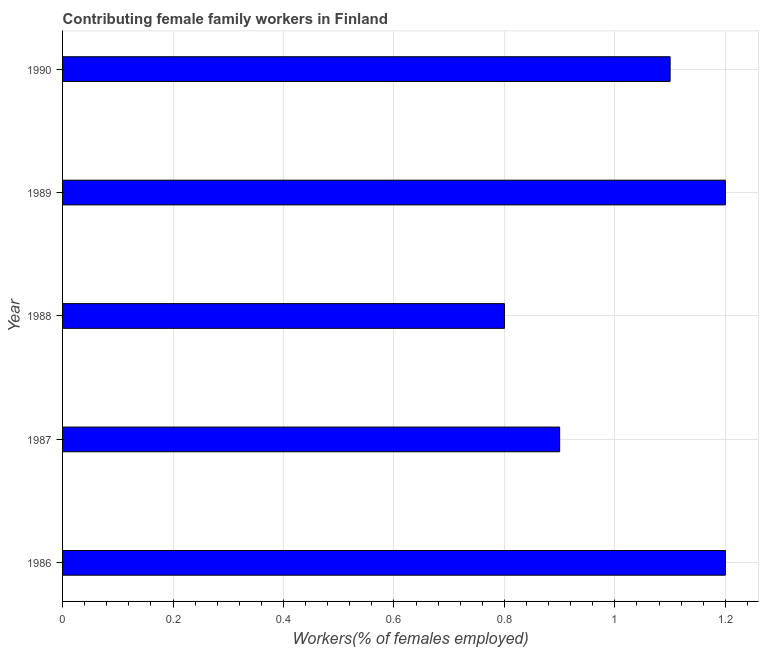What is the title of the graph?
Give a very brief answer. Contributing female family workers in Finland. What is the label or title of the X-axis?
Keep it short and to the point. Workers(% of females employed). What is the contributing female family workers in 1986?
Keep it short and to the point. 1.2. Across all years, what is the maximum contributing female family workers?
Make the answer very short. 1.2. Across all years, what is the minimum contributing female family workers?
Offer a terse response. 0.8. What is the sum of the contributing female family workers?
Your answer should be compact. 5.2. What is the difference between the contributing female family workers in 1989 and 1990?
Make the answer very short. 0.1. What is the average contributing female family workers per year?
Your response must be concise. 1.04. What is the median contributing female family workers?
Your answer should be very brief. 1.1. Do a majority of the years between 1987 and 1989 (inclusive) have contributing female family workers greater than 1 %?
Provide a short and direct response. No. What is the ratio of the contributing female family workers in 1989 to that in 1990?
Your answer should be very brief. 1.09. Is the contributing female family workers in 1988 less than that in 1990?
Make the answer very short. Yes. Is the difference between the contributing female family workers in 1986 and 1988 greater than the difference between any two years?
Your answer should be very brief. Yes. What is the difference between the highest and the lowest contributing female family workers?
Your answer should be compact. 0.4. How many bars are there?
Your answer should be very brief. 5. How many years are there in the graph?
Your answer should be compact. 5. Are the values on the major ticks of X-axis written in scientific E-notation?
Keep it short and to the point. No. What is the Workers(% of females employed) of 1986?
Offer a terse response. 1.2. What is the Workers(% of females employed) of 1987?
Your answer should be very brief. 0.9. What is the Workers(% of females employed) in 1988?
Provide a short and direct response. 0.8. What is the Workers(% of females employed) of 1989?
Offer a very short reply. 1.2. What is the Workers(% of females employed) of 1990?
Make the answer very short. 1.1. What is the difference between the Workers(% of females employed) in 1986 and 1987?
Your answer should be compact. 0.3. What is the difference between the Workers(% of females employed) in 1987 and 1988?
Give a very brief answer. 0.1. What is the difference between the Workers(% of females employed) in 1989 and 1990?
Your answer should be compact. 0.1. What is the ratio of the Workers(% of females employed) in 1986 to that in 1987?
Provide a succinct answer. 1.33. What is the ratio of the Workers(% of females employed) in 1986 to that in 1990?
Your answer should be very brief. 1.09. What is the ratio of the Workers(% of females employed) in 1987 to that in 1990?
Provide a succinct answer. 0.82. What is the ratio of the Workers(% of females employed) in 1988 to that in 1989?
Offer a terse response. 0.67. What is the ratio of the Workers(% of females employed) in 1988 to that in 1990?
Provide a short and direct response. 0.73. What is the ratio of the Workers(% of females employed) in 1989 to that in 1990?
Your answer should be very brief. 1.09. 